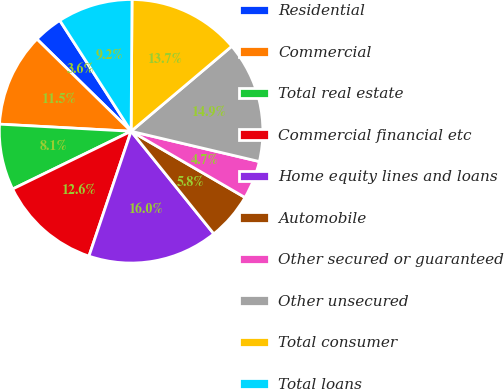<chart> <loc_0><loc_0><loc_500><loc_500><pie_chart><fcel>Residential<fcel>Commercial<fcel>Total real estate<fcel>Commercial financial etc<fcel>Home equity lines and loans<fcel>Automobile<fcel>Other secured or guaranteed<fcel>Other unsecured<fcel>Total consumer<fcel>Total loans<nl><fcel>3.57%<fcel>11.47%<fcel>8.08%<fcel>12.6%<fcel>15.98%<fcel>5.82%<fcel>4.69%<fcel>14.85%<fcel>13.73%<fcel>9.21%<nl></chart> 